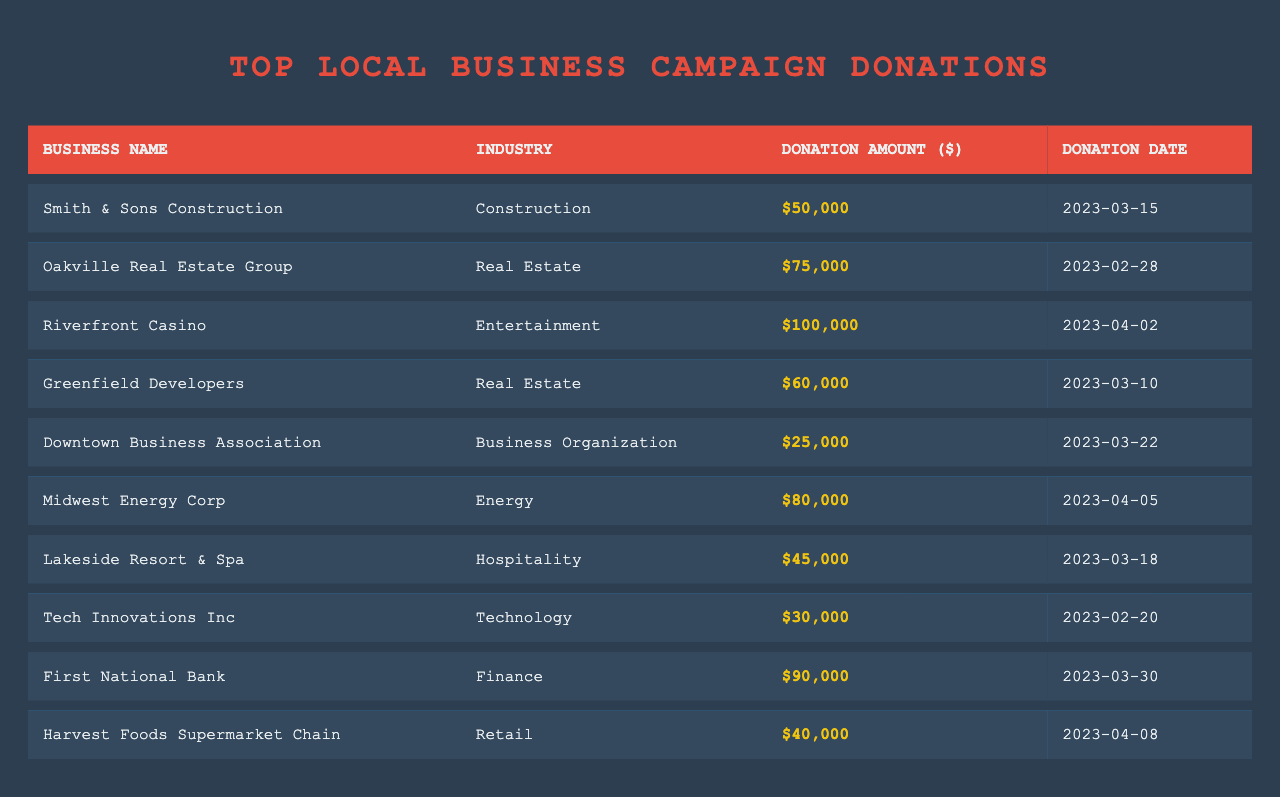What is the highest donation amount listed in the table? The table shows various donation amounts, and by simply scanning the "Donation Amount ($)" column, the highest value is found to be 100,000 from Riverfront Casino.
Answer: 100000 Which business donated the least amount? By reviewing the donation amounts, Downtown Business Association donated the smallest sum of 25,000, which is the lowest value when compared to others.
Answer: 25000 How much did First National Bank donate? The row for First National Bank shows that it donated 90,000, which can be directly retrieved from the "Donation Amount ($)" column.
Answer: 90000 What is the total amount donated by businesses in the Real Estate industry? The Real Estate businesses listed are Oakville Real Estate Group (75,000) and Greenfield Developers (60,000). Summing these amounts results in 75,000 + 60,000 = 135,000.
Answer: 135000 How many businesses donated more than 50,000? By inspecting the donation amounts, the following businesses donated more than 50,000: Riverfront Casino (100,000), First National Bank (90,000), Midwest Energy Corp (80,000), Oakville Real Estate Group (75,000), and Greenfield Developers (60,000). That's a total of 5 businesses.
Answer: 5 Is there any business in the list that belongs to the Hospitality industry? Looking through the industry column, Lakeside Resort & Spa is the only business categorized under Hospitality. Therefore, the answer is yes.
Answer: Yes What is the average donation amount across all businesses? The total donations sum up to 425,000 (50000 + 75000 + 100000 + 60000 + 25000 + 80000 + 45000 + 30000 + 90000 + 40000). There are 10 businesses, so the average donation is 425,000 / 10 = 42,500.
Answer: 42500 Which industry received the highest total donation, and what is that amount? The industries and their total donations are: Construction (50,000), Real Estate (135,000), Entertainment (100,000), Business Organization (25,000), Energy (80,000), Hospitality (45,000), Technology (30,000), Finance (90,000), and Retail (40,000). The highest total is for the Real Estate industry at 135,000.
Answer: Real Estate, 135000 Was there a donation on the date 2023-03-22, and if so, who made it? The table indicates that on 2023-03-22, the Downtown Business Association made a donation of 25,000. Therefore, yes, there was a donation made on that date.
Answer: Yes, Downtown Business Association What percentage of the total donations comes from the top three donors? The top three donations are from Riverfront Casino (100,000), First National Bank (90,000), and Midwest Energy Corp (80,000), totaling to 270,000. The total donations amount to 425,000, so the percentage is (270,000 / 425,000) * 100 ≈ 63.53%.
Answer: Approximately 63.53% 